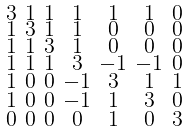Convert formula to latex. <formula><loc_0><loc_0><loc_500><loc_500>\begin{smallmatrix} 3 & 1 & 1 & 1 & 1 & 1 & 0 \\ 1 & 3 & 1 & 1 & 0 & 0 & 0 \\ 1 & 1 & 3 & 1 & 0 & 0 & 0 \\ 1 & 1 & 1 & 3 & - 1 & - 1 & 0 \\ 1 & 0 & 0 & - 1 & 3 & 1 & 1 \\ 1 & 0 & 0 & - 1 & 1 & 3 & 0 \\ 0 & 0 & 0 & 0 & 1 & 0 & 3 \end{smallmatrix}</formula> 